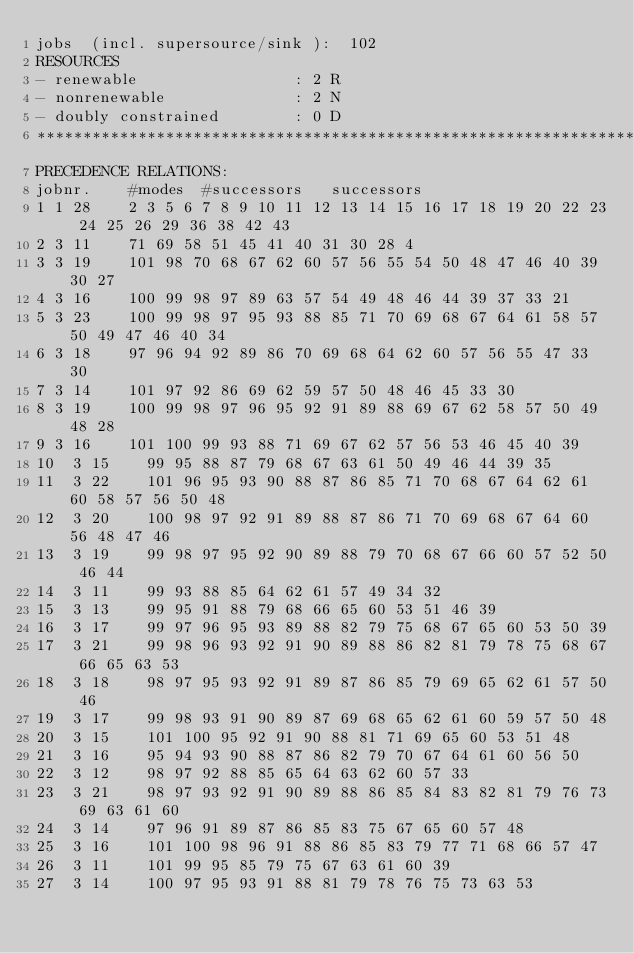Convert code to text. <code><loc_0><loc_0><loc_500><loc_500><_ObjectiveC_>jobs  (incl. supersource/sink ):	102
RESOURCES
- renewable                 : 2 R
- nonrenewable              : 2 N
- doubly constrained        : 0 D
************************************************************************
PRECEDENCE RELATIONS:
jobnr.    #modes  #successors   successors
1	1	28		2 3 5 6 7 8 9 10 11 12 13 14 15 16 17 18 19 20 22 23 24 25 26 29 36 38 42 43 
2	3	11		71 69 58 51 45 41 40 31 30 28 4 
3	3	19		101 98 70 68 67 62 60 57 56 55 54 50 48 47 46 40 39 30 27 
4	3	16		100 99 98 97 89 63 57 54 49 48 46 44 39 37 33 21 
5	3	23		100 99 98 97 95 93 88 85 71 70 69 68 67 64 61 58 57 50 49 47 46 40 34 
6	3	18		97 96 94 92 89 86 70 69 68 64 62 60 57 56 55 47 33 30 
7	3	14		101 97 92 86 69 62 59 57 50 48 46 45 33 30 
8	3	19		100 99 98 97 96 95 92 91 89 88 69 67 62 58 57 50 49 48 28 
9	3	16		101 100 99 93 88 71 69 67 62 57 56 53 46 45 40 39 
10	3	15		99 95 88 87 79 68 67 63 61 50 49 46 44 39 35 
11	3	22		101 96 95 93 90 88 87 86 85 71 70 68 67 64 62 61 60 58 57 56 50 48 
12	3	20		100 98 97 92 91 89 88 87 86 71 70 69 68 67 64 60 56 48 47 46 
13	3	19		99 98 97 95 92 90 89 88 79 70 68 67 66 60 57 52 50 46 44 
14	3	11		99 93 88 85 64 62 61 57 49 34 32 
15	3	13		99 95 91 88 79 68 66 65 60 53 51 46 39 
16	3	17		99 97 96 95 93 89 88 82 79 75 68 67 65 60 53 50 39 
17	3	21		99 98 96 93 92 91 90 89 88 86 82 81 79 78 75 68 67 66 65 63 53 
18	3	18		98 97 95 93 92 91 89 87 86 85 79 69 65 62 61 57 50 46 
19	3	17		99 98 93 91 90 89 87 69 68 65 62 61 60 59 57 50 48 
20	3	15		101 100 95 92 91 90 88 81 71 69 65 60 53 51 48 
21	3	16		95 94 93 90 88 87 86 82 79 70 67 64 61 60 56 50 
22	3	12		98 97 92 88 85 65 64 63 62 60 57 33 
23	3	21		98 97 93 92 91 90 89 88 86 85 84 83 82 81 79 76 73 69 63 61 60 
24	3	14		97 96 91 89 87 86 85 83 75 67 65 60 57 48 
25	3	16		101 100 98 96 91 88 86 85 83 79 77 71 68 66 57 47 
26	3	11		101 99 95 85 79 75 67 63 61 60 39 
27	3	14		100 97 95 93 91 88 81 79 78 76 75 73 63 53 </code> 